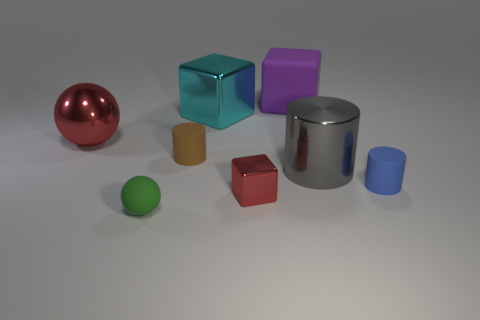What number of purple matte cubes are there?
Your answer should be very brief. 1. There is a big thing that is in front of the shiny thing on the left side of the green matte object right of the big red metal ball; what is its material?
Your answer should be compact. Metal. Are there any blue objects made of the same material as the purple object?
Give a very brief answer. Yes. Is the material of the tiny blue object the same as the small green sphere?
Offer a terse response. Yes. What number of cylinders are big purple matte objects or brown objects?
Offer a terse response. 1. What is the color of the small ball that is made of the same material as the large purple block?
Offer a very short reply. Green. Are there fewer brown rubber things than cylinders?
Keep it short and to the point. Yes. There is a small rubber thing that is to the right of the large purple block; is it the same shape as the large metallic object that is to the right of the cyan metal thing?
Ensure brevity in your answer.  Yes. How many objects are either red objects or cyan shiny things?
Make the answer very short. 3. What is the color of the metal block that is the same size as the green thing?
Your answer should be very brief. Red. 